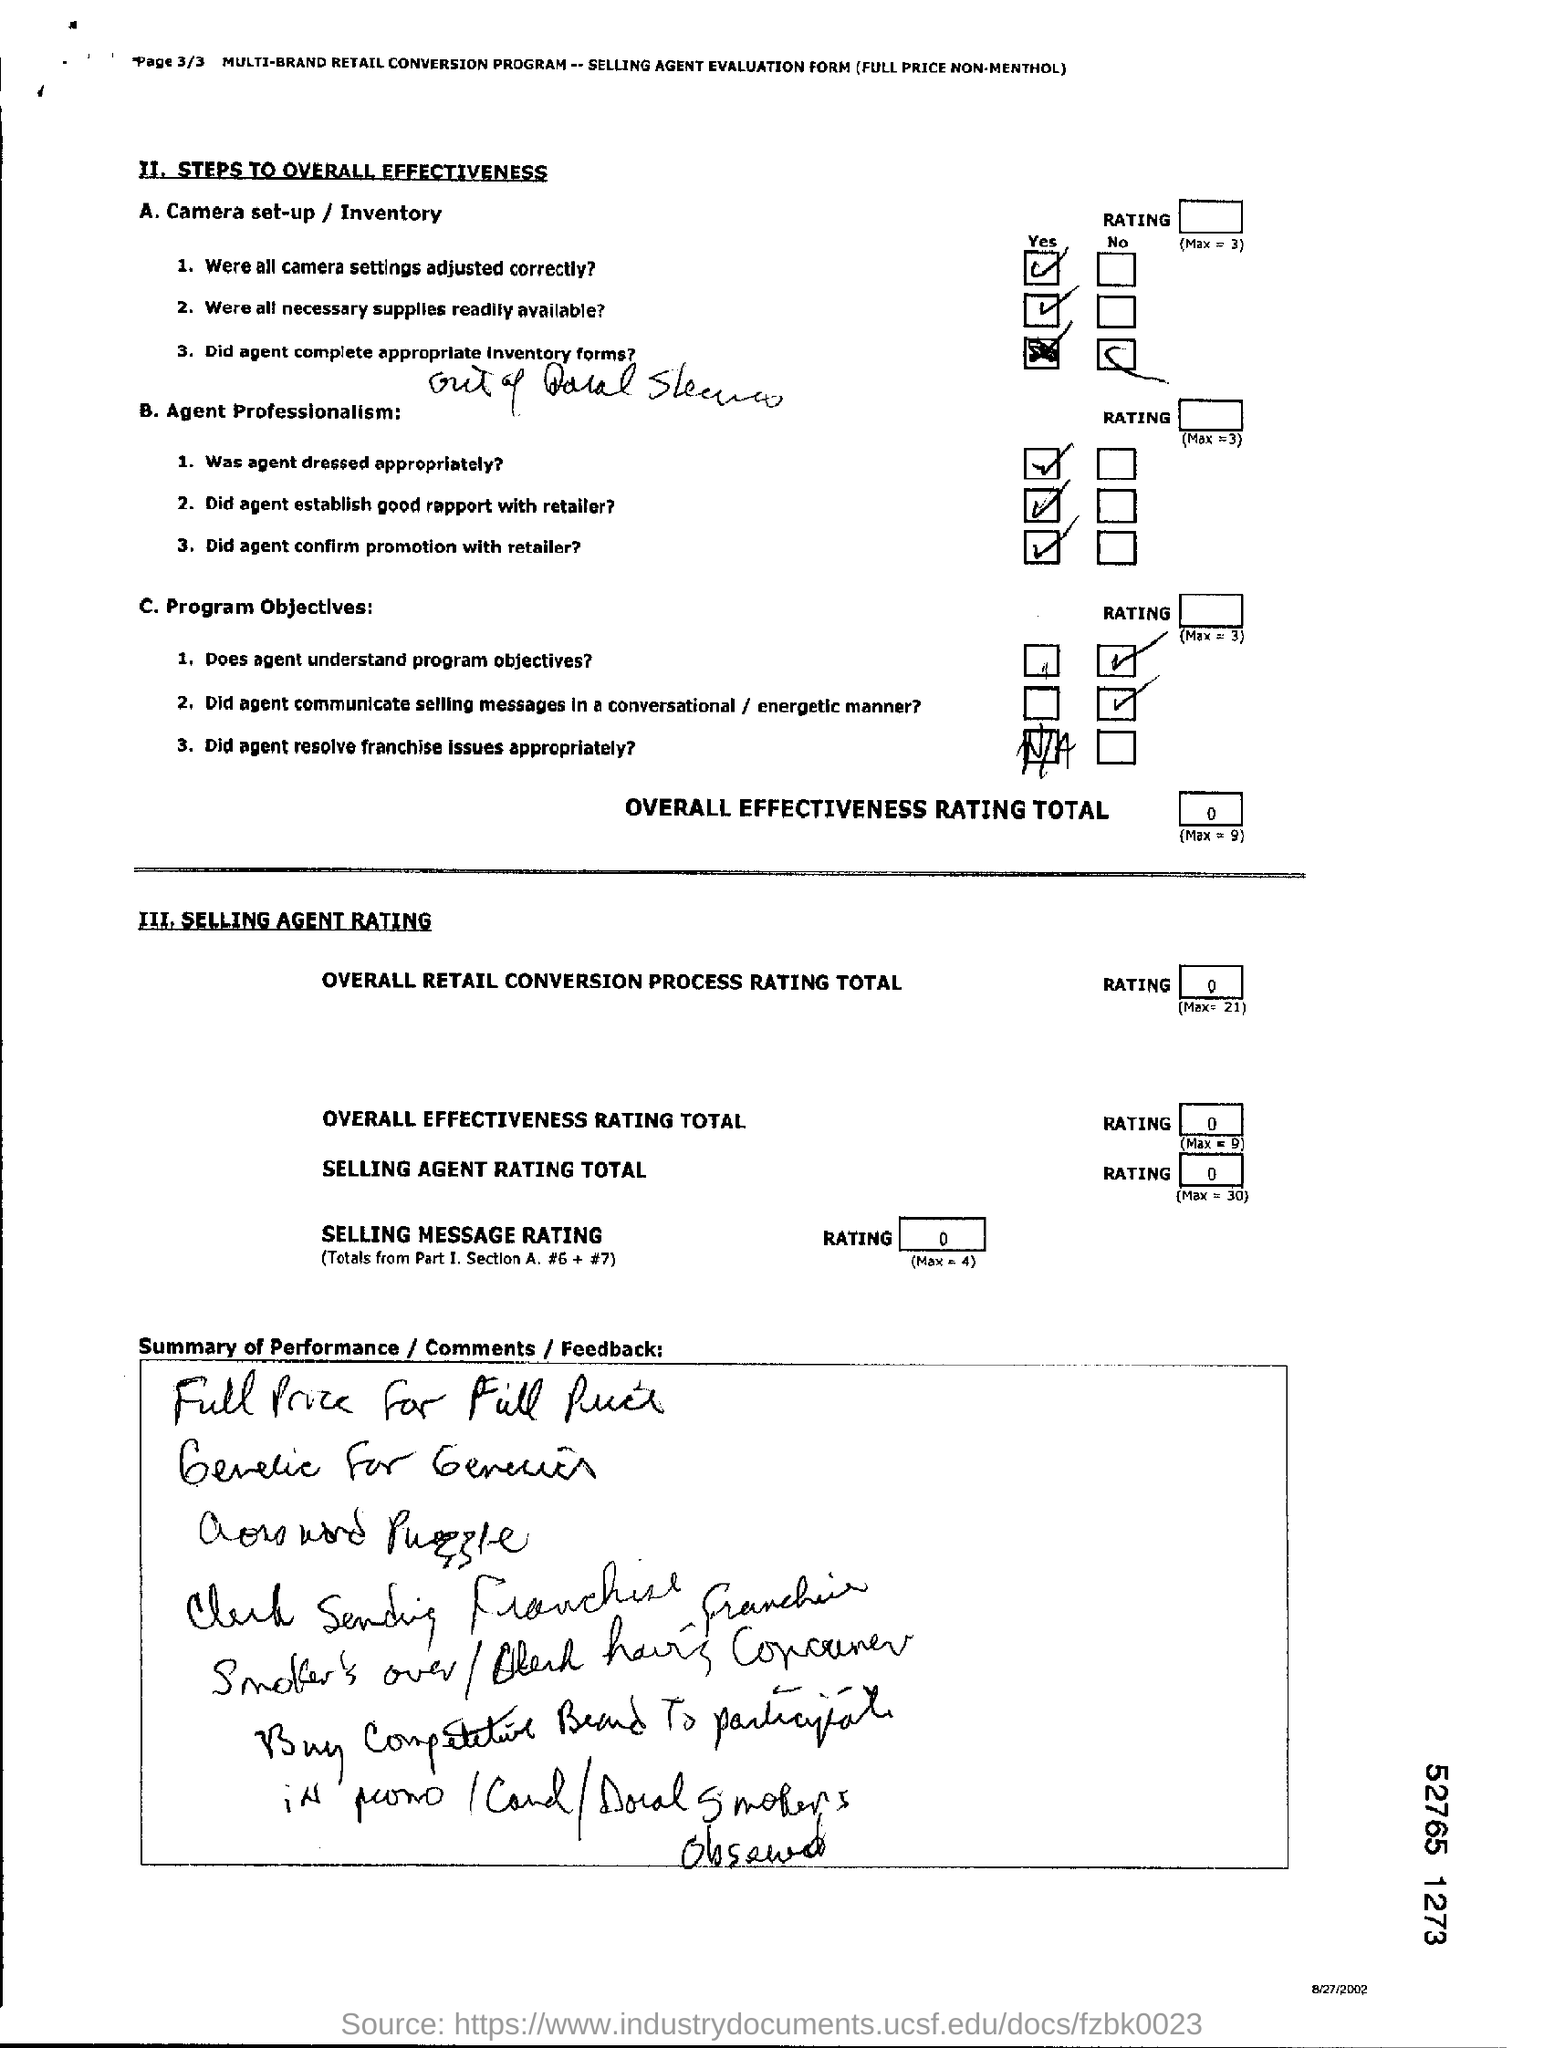What can you infer about the performance of the agent from the completed sections? The form in the image has been partially filled with several 'Yes' checks, implying that certain listed tasks were completed satisfactorily, such as camera setup and inventory. Agent professionalism also received positive marks. However, there's an unchecked item under program objectives, and the overall effectiveness rating total is marked as zero out of nine, suggesting that there were some deficiencies in performance or objectives that were not met. Additionally, the handwritten comments seem to reflect mixed feedback or notes, mentioning terms like 'promotions', 'consumer', and possibly 'discounts', which could relate to the specifics of the job performance or sales strategies. 